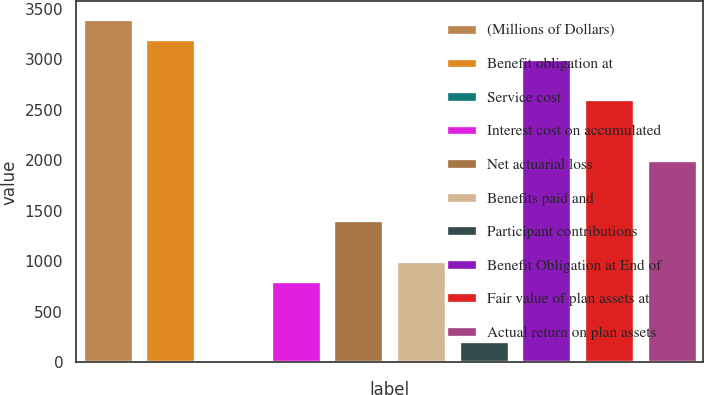<chart> <loc_0><loc_0><loc_500><loc_500><bar_chart><fcel>(Millions of Dollars)<fcel>Benefit obligation at<fcel>Service cost<fcel>Interest cost on accumulated<fcel>Net actuarial loss<fcel>Benefits paid and<fcel>Participant contributions<fcel>Benefit Obligation at End of<fcel>Fair value of plan assets at<fcel>Actual return on plan assets<nl><fcel>3399.5<fcel>3200<fcel>8<fcel>806<fcel>1404.5<fcel>1005.5<fcel>207.5<fcel>3000.5<fcel>2601.5<fcel>2003<nl></chart> 